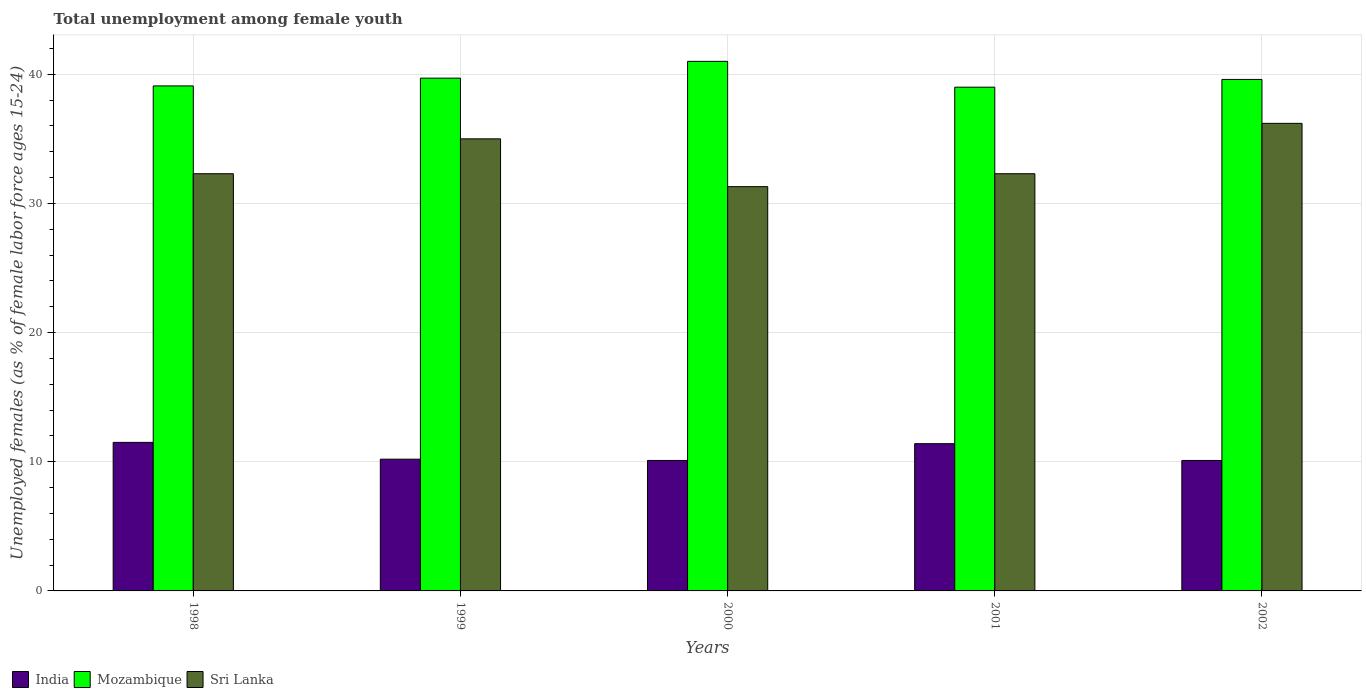Are the number of bars on each tick of the X-axis equal?
Ensure brevity in your answer.  Yes. How many bars are there on the 1st tick from the left?
Keep it short and to the point. 3. How many bars are there on the 4th tick from the right?
Give a very brief answer. 3. Across all years, what is the maximum percentage of unemployed females in in Sri Lanka?
Ensure brevity in your answer.  36.2. Across all years, what is the minimum percentage of unemployed females in in Mozambique?
Make the answer very short. 39. In which year was the percentage of unemployed females in in India maximum?
Provide a succinct answer. 1998. In which year was the percentage of unemployed females in in Mozambique minimum?
Offer a very short reply. 2001. What is the total percentage of unemployed females in in Sri Lanka in the graph?
Keep it short and to the point. 167.1. What is the difference between the percentage of unemployed females in in Mozambique in 2000 and that in 2002?
Provide a succinct answer. 1.4. What is the difference between the percentage of unemployed females in in Mozambique in 2002 and the percentage of unemployed females in in Sri Lanka in 1999?
Give a very brief answer. 4.6. What is the average percentage of unemployed females in in India per year?
Your response must be concise. 10.66. In the year 2001, what is the difference between the percentage of unemployed females in in India and percentage of unemployed females in in Sri Lanka?
Offer a very short reply. -20.9. In how many years, is the percentage of unemployed females in in Mozambique greater than 20 %?
Your response must be concise. 5. What is the ratio of the percentage of unemployed females in in Mozambique in 2000 to that in 2002?
Provide a succinct answer. 1.04. Is the difference between the percentage of unemployed females in in India in 1998 and 2002 greater than the difference between the percentage of unemployed females in in Sri Lanka in 1998 and 2002?
Make the answer very short. Yes. What is the difference between the highest and the second highest percentage of unemployed females in in Sri Lanka?
Your response must be concise. 1.2. What is the difference between the highest and the lowest percentage of unemployed females in in India?
Your answer should be compact. 1.4. In how many years, is the percentage of unemployed females in in India greater than the average percentage of unemployed females in in India taken over all years?
Provide a short and direct response. 2. What does the 3rd bar from the left in 1999 represents?
Provide a succinct answer. Sri Lanka. What does the 1st bar from the right in 2000 represents?
Ensure brevity in your answer.  Sri Lanka. Are all the bars in the graph horizontal?
Keep it short and to the point. No. How many years are there in the graph?
Your answer should be very brief. 5. What is the title of the graph?
Provide a succinct answer. Total unemployment among female youth. What is the label or title of the X-axis?
Give a very brief answer. Years. What is the label or title of the Y-axis?
Give a very brief answer. Unemployed females (as % of female labor force ages 15-24). What is the Unemployed females (as % of female labor force ages 15-24) in India in 1998?
Offer a terse response. 11.5. What is the Unemployed females (as % of female labor force ages 15-24) of Mozambique in 1998?
Your answer should be compact. 39.1. What is the Unemployed females (as % of female labor force ages 15-24) in Sri Lanka in 1998?
Give a very brief answer. 32.3. What is the Unemployed females (as % of female labor force ages 15-24) of India in 1999?
Give a very brief answer. 10.2. What is the Unemployed females (as % of female labor force ages 15-24) of Mozambique in 1999?
Ensure brevity in your answer.  39.7. What is the Unemployed females (as % of female labor force ages 15-24) in India in 2000?
Provide a succinct answer. 10.1. What is the Unemployed females (as % of female labor force ages 15-24) of Sri Lanka in 2000?
Keep it short and to the point. 31.3. What is the Unemployed females (as % of female labor force ages 15-24) in India in 2001?
Provide a succinct answer. 11.4. What is the Unemployed females (as % of female labor force ages 15-24) of Mozambique in 2001?
Offer a terse response. 39. What is the Unemployed females (as % of female labor force ages 15-24) in Sri Lanka in 2001?
Give a very brief answer. 32.3. What is the Unemployed females (as % of female labor force ages 15-24) in India in 2002?
Give a very brief answer. 10.1. What is the Unemployed females (as % of female labor force ages 15-24) in Mozambique in 2002?
Ensure brevity in your answer.  39.6. What is the Unemployed females (as % of female labor force ages 15-24) of Sri Lanka in 2002?
Your response must be concise. 36.2. Across all years, what is the maximum Unemployed females (as % of female labor force ages 15-24) in India?
Offer a very short reply. 11.5. Across all years, what is the maximum Unemployed females (as % of female labor force ages 15-24) in Mozambique?
Your answer should be compact. 41. Across all years, what is the maximum Unemployed females (as % of female labor force ages 15-24) in Sri Lanka?
Ensure brevity in your answer.  36.2. Across all years, what is the minimum Unemployed females (as % of female labor force ages 15-24) of India?
Offer a very short reply. 10.1. Across all years, what is the minimum Unemployed females (as % of female labor force ages 15-24) of Mozambique?
Ensure brevity in your answer.  39. Across all years, what is the minimum Unemployed females (as % of female labor force ages 15-24) of Sri Lanka?
Give a very brief answer. 31.3. What is the total Unemployed females (as % of female labor force ages 15-24) in India in the graph?
Ensure brevity in your answer.  53.3. What is the total Unemployed females (as % of female labor force ages 15-24) of Mozambique in the graph?
Ensure brevity in your answer.  198.4. What is the total Unemployed females (as % of female labor force ages 15-24) of Sri Lanka in the graph?
Keep it short and to the point. 167.1. What is the difference between the Unemployed females (as % of female labor force ages 15-24) of Sri Lanka in 1998 and that in 1999?
Make the answer very short. -2.7. What is the difference between the Unemployed females (as % of female labor force ages 15-24) of India in 1998 and that in 2000?
Your answer should be very brief. 1.4. What is the difference between the Unemployed females (as % of female labor force ages 15-24) in Sri Lanka in 1998 and that in 2000?
Offer a terse response. 1. What is the difference between the Unemployed females (as % of female labor force ages 15-24) of Mozambique in 1998 and that in 2001?
Your answer should be very brief. 0.1. What is the difference between the Unemployed females (as % of female labor force ages 15-24) in India in 1998 and that in 2002?
Ensure brevity in your answer.  1.4. What is the difference between the Unemployed females (as % of female labor force ages 15-24) in Sri Lanka in 1998 and that in 2002?
Make the answer very short. -3.9. What is the difference between the Unemployed females (as % of female labor force ages 15-24) in Sri Lanka in 1999 and that in 2000?
Your answer should be very brief. 3.7. What is the difference between the Unemployed females (as % of female labor force ages 15-24) in Mozambique in 1999 and that in 2002?
Keep it short and to the point. 0.1. What is the difference between the Unemployed females (as % of female labor force ages 15-24) in Sri Lanka in 1999 and that in 2002?
Your answer should be compact. -1.2. What is the difference between the Unemployed females (as % of female labor force ages 15-24) in India in 2000 and that in 2001?
Provide a succinct answer. -1.3. What is the difference between the Unemployed females (as % of female labor force ages 15-24) in Sri Lanka in 2000 and that in 2001?
Your answer should be very brief. -1. What is the difference between the Unemployed females (as % of female labor force ages 15-24) in India in 2000 and that in 2002?
Offer a very short reply. 0. What is the difference between the Unemployed females (as % of female labor force ages 15-24) of Mozambique in 2000 and that in 2002?
Your answer should be compact. 1.4. What is the difference between the Unemployed females (as % of female labor force ages 15-24) of India in 2001 and that in 2002?
Provide a short and direct response. 1.3. What is the difference between the Unemployed females (as % of female labor force ages 15-24) of Mozambique in 2001 and that in 2002?
Offer a terse response. -0.6. What is the difference between the Unemployed females (as % of female labor force ages 15-24) of Sri Lanka in 2001 and that in 2002?
Give a very brief answer. -3.9. What is the difference between the Unemployed females (as % of female labor force ages 15-24) of India in 1998 and the Unemployed females (as % of female labor force ages 15-24) of Mozambique in 1999?
Provide a succinct answer. -28.2. What is the difference between the Unemployed females (as % of female labor force ages 15-24) in India in 1998 and the Unemployed females (as % of female labor force ages 15-24) in Sri Lanka in 1999?
Ensure brevity in your answer.  -23.5. What is the difference between the Unemployed females (as % of female labor force ages 15-24) in Mozambique in 1998 and the Unemployed females (as % of female labor force ages 15-24) in Sri Lanka in 1999?
Give a very brief answer. 4.1. What is the difference between the Unemployed females (as % of female labor force ages 15-24) of India in 1998 and the Unemployed females (as % of female labor force ages 15-24) of Mozambique in 2000?
Your answer should be compact. -29.5. What is the difference between the Unemployed females (as % of female labor force ages 15-24) of India in 1998 and the Unemployed females (as % of female labor force ages 15-24) of Sri Lanka in 2000?
Your response must be concise. -19.8. What is the difference between the Unemployed females (as % of female labor force ages 15-24) of Mozambique in 1998 and the Unemployed females (as % of female labor force ages 15-24) of Sri Lanka in 2000?
Keep it short and to the point. 7.8. What is the difference between the Unemployed females (as % of female labor force ages 15-24) in India in 1998 and the Unemployed females (as % of female labor force ages 15-24) in Mozambique in 2001?
Provide a short and direct response. -27.5. What is the difference between the Unemployed females (as % of female labor force ages 15-24) of India in 1998 and the Unemployed females (as % of female labor force ages 15-24) of Sri Lanka in 2001?
Give a very brief answer. -20.8. What is the difference between the Unemployed females (as % of female labor force ages 15-24) in India in 1998 and the Unemployed females (as % of female labor force ages 15-24) in Mozambique in 2002?
Give a very brief answer. -28.1. What is the difference between the Unemployed females (as % of female labor force ages 15-24) of India in 1998 and the Unemployed females (as % of female labor force ages 15-24) of Sri Lanka in 2002?
Offer a terse response. -24.7. What is the difference between the Unemployed females (as % of female labor force ages 15-24) in Mozambique in 1998 and the Unemployed females (as % of female labor force ages 15-24) in Sri Lanka in 2002?
Provide a short and direct response. 2.9. What is the difference between the Unemployed females (as % of female labor force ages 15-24) of India in 1999 and the Unemployed females (as % of female labor force ages 15-24) of Mozambique in 2000?
Give a very brief answer. -30.8. What is the difference between the Unemployed females (as % of female labor force ages 15-24) of India in 1999 and the Unemployed females (as % of female labor force ages 15-24) of Sri Lanka in 2000?
Provide a short and direct response. -21.1. What is the difference between the Unemployed females (as % of female labor force ages 15-24) of India in 1999 and the Unemployed females (as % of female labor force ages 15-24) of Mozambique in 2001?
Your answer should be very brief. -28.8. What is the difference between the Unemployed females (as % of female labor force ages 15-24) of India in 1999 and the Unemployed females (as % of female labor force ages 15-24) of Sri Lanka in 2001?
Your answer should be very brief. -22.1. What is the difference between the Unemployed females (as % of female labor force ages 15-24) of Mozambique in 1999 and the Unemployed females (as % of female labor force ages 15-24) of Sri Lanka in 2001?
Keep it short and to the point. 7.4. What is the difference between the Unemployed females (as % of female labor force ages 15-24) of India in 1999 and the Unemployed females (as % of female labor force ages 15-24) of Mozambique in 2002?
Keep it short and to the point. -29.4. What is the difference between the Unemployed females (as % of female labor force ages 15-24) in India in 1999 and the Unemployed females (as % of female labor force ages 15-24) in Sri Lanka in 2002?
Your response must be concise. -26. What is the difference between the Unemployed females (as % of female labor force ages 15-24) in India in 2000 and the Unemployed females (as % of female labor force ages 15-24) in Mozambique in 2001?
Your answer should be very brief. -28.9. What is the difference between the Unemployed females (as % of female labor force ages 15-24) of India in 2000 and the Unemployed females (as % of female labor force ages 15-24) of Sri Lanka in 2001?
Your response must be concise. -22.2. What is the difference between the Unemployed females (as % of female labor force ages 15-24) of India in 2000 and the Unemployed females (as % of female labor force ages 15-24) of Mozambique in 2002?
Make the answer very short. -29.5. What is the difference between the Unemployed females (as % of female labor force ages 15-24) in India in 2000 and the Unemployed females (as % of female labor force ages 15-24) in Sri Lanka in 2002?
Your answer should be compact. -26.1. What is the difference between the Unemployed females (as % of female labor force ages 15-24) of Mozambique in 2000 and the Unemployed females (as % of female labor force ages 15-24) of Sri Lanka in 2002?
Your answer should be compact. 4.8. What is the difference between the Unemployed females (as % of female labor force ages 15-24) in India in 2001 and the Unemployed females (as % of female labor force ages 15-24) in Mozambique in 2002?
Give a very brief answer. -28.2. What is the difference between the Unemployed females (as % of female labor force ages 15-24) of India in 2001 and the Unemployed females (as % of female labor force ages 15-24) of Sri Lanka in 2002?
Make the answer very short. -24.8. What is the difference between the Unemployed females (as % of female labor force ages 15-24) in Mozambique in 2001 and the Unemployed females (as % of female labor force ages 15-24) in Sri Lanka in 2002?
Give a very brief answer. 2.8. What is the average Unemployed females (as % of female labor force ages 15-24) of India per year?
Provide a succinct answer. 10.66. What is the average Unemployed females (as % of female labor force ages 15-24) in Mozambique per year?
Your answer should be very brief. 39.68. What is the average Unemployed females (as % of female labor force ages 15-24) of Sri Lanka per year?
Your answer should be compact. 33.42. In the year 1998, what is the difference between the Unemployed females (as % of female labor force ages 15-24) of India and Unemployed females (as % of female labor force ages 15-24) of Mozambique?
Offer a terse response. -27.6. In the year 1998, what is the difference between the Unemployed females (as % of female labor force ages 15-24) in India and Unemployed females (as % of female labor force ages 15-24) in Sri Lanka?
Your response must be concise. -20.8. In the year 1998, what is the difference between the Unemployed females (as % of female labor force ages 15-24) of Mozambique and Unemployed females (as % of female labor force ages 15-24) of Sri Lanka?
Offer a terse response. 6.8. In the year 1999, what is the difference between the Unemployed females (as % of female labor force ages 15-24) in India and Unemployed females (as % of female labor force ages 15-24) in Mozambique?
Offer a very short reply. -29.5. In the year 1999, what is the difference between the Unemployed females (as % of female labor force ages 15-24) of India and Unemployed females (as % of female labor force ages 15-24) of Sri Lanka?
Keep it short and to the point. -24.8. In the year 2000, what is the difference between the Unemployed females (as % of female labor force ages 15-24) in India and Unemployed females (as % of female labor force ages 15-24) in Mozambique?
Offer a terse response. -30.9. In the year 2000, what is the difference between the Unemployed females (as % of female labor force ages 15-24) in India and Unemployed females (as % of female labor force ages 15-24) in Sri Lanka?
Keep it short and to the point. -21.2. In the year 2000, what is the difference between the Unemployed females (as % of female labor force ages 15-24) in Mozambique and Unemployed females (as % of female labor force ages 15-24) in Sri Lanka?
Your response must be concise. 9.7. In the year 2001, what is the difference between the Unemployed females (as % of female labor force ages 15-24) of India and Unemployed females (as % of female labor force ages 15-24) of Mozambique?
Provide a succinct answer. -27.6. In the year 2001, what is the difference between the Unemployed females (as % of female labor force ages 15-24) in India and Unemployed females (as % of female labor force ages 15-24) in Sri Lanka?
Your response must be concise. -20.9. In the year 2002, what is the difference between the Unemployed females (as % of female labor force ages 15-24) of India and Unemployed females (as % of female labor force ages 15-24) of Mozambique?
Give a very brief answer. -29.5. In the year 2002, what is the difference between the Unemployed females (as % of female labor force ages 15-24) of India and Unemployed females (as % of female labor force ages 15-24) of Sri Lanka?
Give a very brief answer. -26.1. What is the ratio of the Unemployed females (as % of female labor force ages 15-24) of India in 1998 to that in 1999?
Offer a terse response. 1.13. What is the ratio of the Unemployed females (as % of female labor force ages 15-24) of Mozambique in 1998 to that in 1999?
Provide a short and direct response. 0.98. What is the ratio of the Unemployed females (as % of female labor force ages 15-24) in Sri Lanka in 1998 to that in 1999?
Keep it short and to the point. 0.92. What is the ratio of the Unemployed females (as % of female labor force ages 15-24) in India in 1998 to that in 2000?
Provide a short and direct response. 1.14. What is the ratio of the Unemployed females (as % of female labor force ages 15-24) of Mozambique in 1998 to that in 2000?
Your response must be concise. 0.95. What is the ratio of the Unemployed females (as % of female labor force ages 15-24) of Sri Lanka in 1998 to that in 2000?
Ensure brevity in your answer.  1.03. What is the ratio of the Unemployed females (as % of female labor force ages 15-24) of India in 1998 to that in 2001?
Provide a succinct answer. 1.01. What is the ratio of the Unemployed females (as % of female labor force ages 15-24) in Mozambique in 1998 to that in 2001?
Ensure brevity in your answer.  1. What is the ratio of the Unemployed females (as % of female labor force ages 15-24) in India in 1998 to that in 2002?
Give a very brief answer. 1.14. What is the ratio of the Unemployed females (as % of female labor force ages 15-24) of Mozambique in 1998 to that in 2002?
Your answer should be compact. 0.99. What is the ratio of the Unemployed females (as % of female labor force ages 15-24) of Sri Lanka in 1998 to that in 2002?
Your answer should be very brief. 0.89. What is the ratio of the Unemployed females (as % of female labor force ages 15-24) in India in 1999 to that in 2000?
Your answer should be very brief. 1.01. What is the ratio of the Unemployed females (as % of female labor force ages 15-24) of Mozambique in 1999 to that in 2000?
Make the answer very short. 0.97. What is the ratio of the Unemployed females (as % of female labor force ages 15-24) of Sri Lanka in 1999 to that in 2000?
Make the answer very short. 1.12. What is the ratio of the Unemployed females (as % of female labor force ages 15-24) in India in 1999 to that in 2001?
Keep it short and to the point. 0.89. What is the ratio of the Unemployed females (as % of female labor force ages 15-24) of Mozambique in 1999 to that in 2001?
Your response must be concise. 1.02. What is the ratio of the Unemployed females (as % of female labor force ages 15-24) of Sri Lanka in 1999 to that in 2001?
Your answer should be compact. 1.08. What is the ratio of the Unemployed females (as % of female labor force ages 15-24) of India in 1999 to that in 2002?
Your answer should be compact. 1.01. What is the ratio of the Unemployed females (as % of female labor force ages 15-24) in Mozambique in 1999 to that in 2002?
Your response must be concise. 1. What is the ratio of the Unemployed females (as % of female labor force ages 15-24) of Sri Lanka in 1999 to that in 2002?
Provide a short and direct response. 0.97. What is the ratio of the Unemployed females (as % of female labor force ages 15-24) of India in 2000 to that in 2001?
Your response must be concise. 0.89. What is the ratio of the Unemployed females (as % of female labor force ages 15-24) of Mozambique in 2000 to that in 2001?
Offer a very short reply. 1.05. What is the ratio of the Unemployed females (as % of female labor force ages 15-24) in Mozambique in 2000 to that in 2002?
Your answer should be compact. 1.04. What is the ratio of the Unemployed females (as % of female labor force ages 15-24) in Sri Lanka in 2000 to that in 2002?
Make the answer very short. 0.86. What is the ratio of the Unemployed females (as % of female labor force ages 15-24) of India in 2001 to that in 2002?
Your answer should be very brief. 1.13. What is the ratio of the Unemployed females (as % of female labor force ages 15-24) of Sri Lanka in 2001 to that in 2002?
Offer a terse response. 0.89. What is the difference between the highest and the second highest Unemployed females (as % of female labor force ages 15-24) in India?
Your response must be concise. 0.1. What is the difference between the highest and the second highest Unemployed females (as % of female labor force ages 15-24) in Mozambique?
Give a very brief answer. 1.3. What is the difference between the highest and the lowest Unemployed females (as % of female labor force ages 15-24) in Mozambique?
Make the answer very short. 2. What is the difference between the highest and the lowest Unemployed females (as % of female labor force ages 15-24) in Sri Lanka?
Provide a succinct answer. 4.9. 